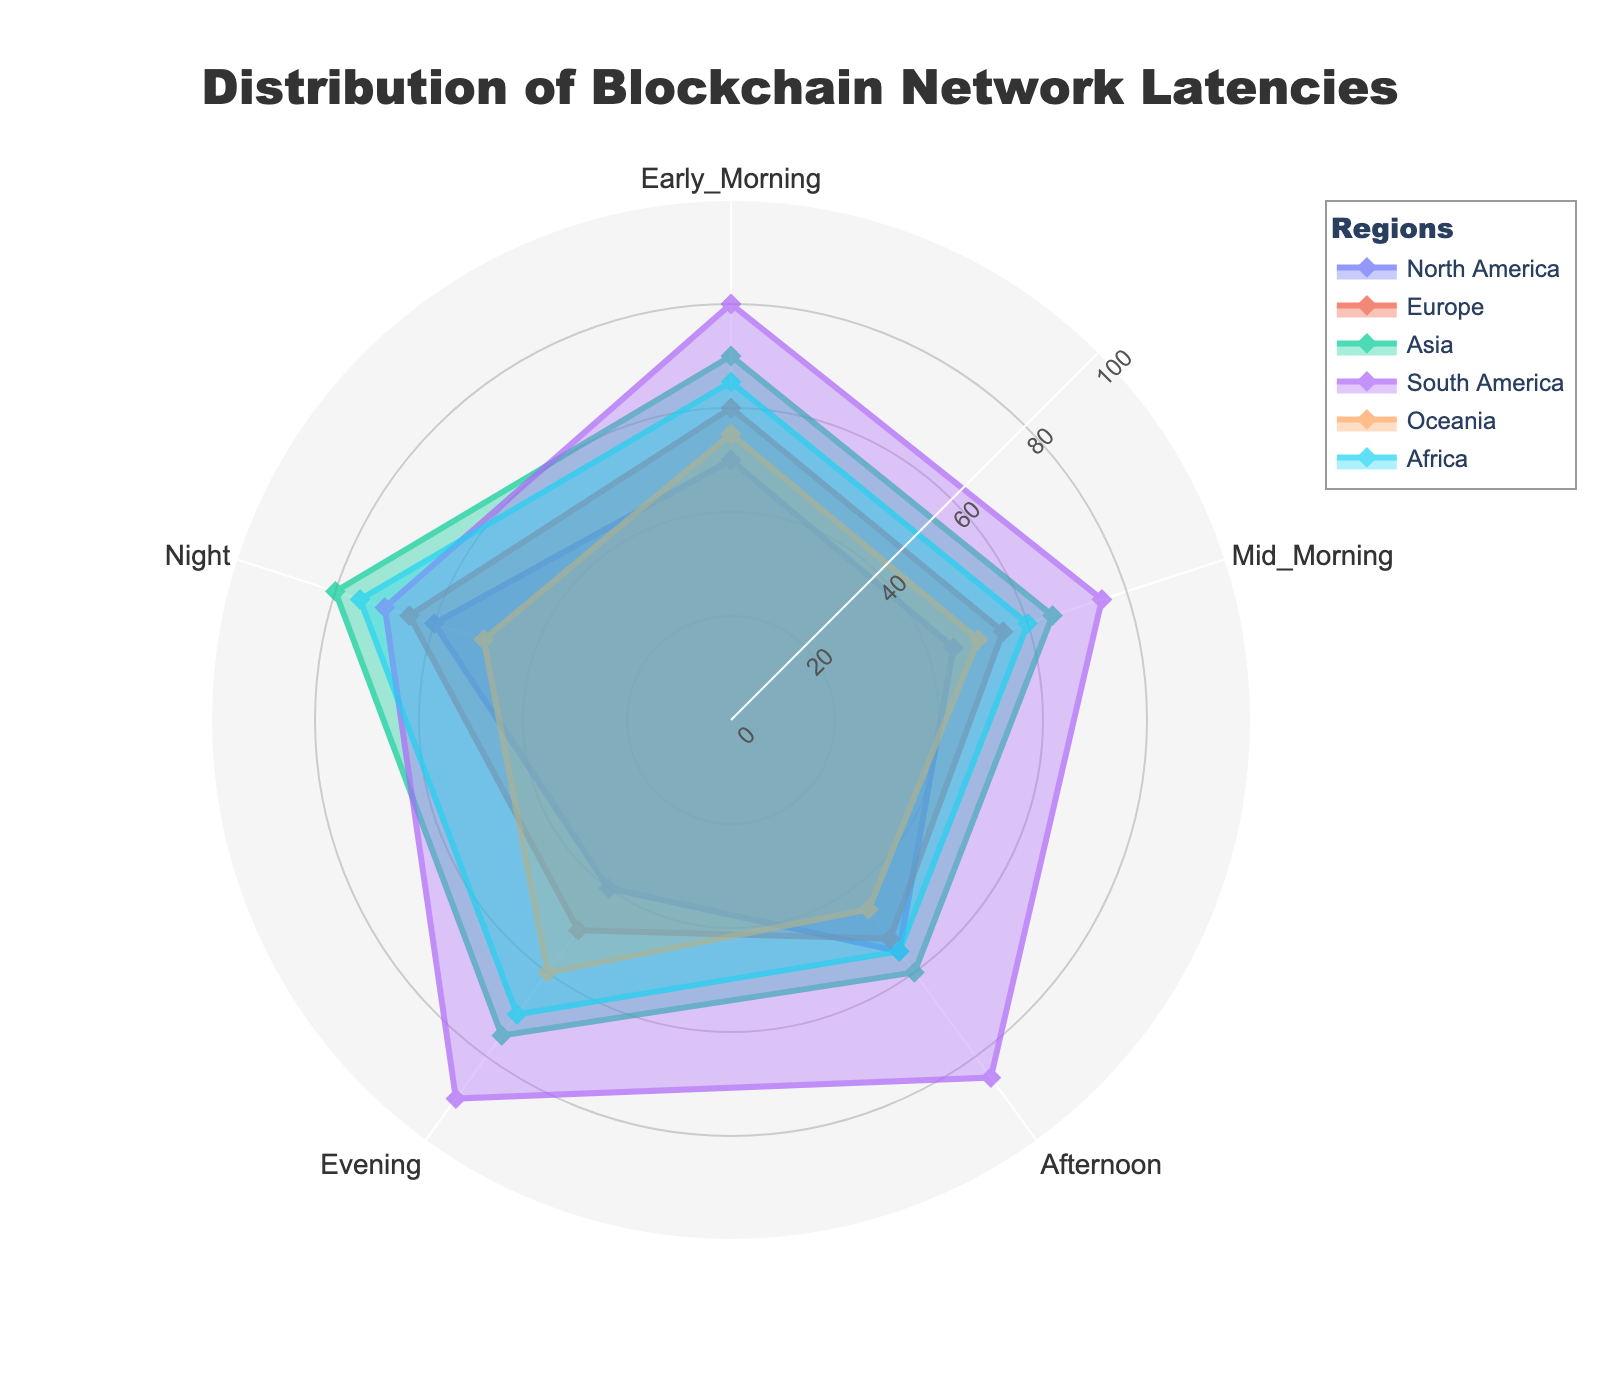What's the title of the radar chart? The title of the radar chart is written at the top center of the figure. It reads "Distribution of Blockchain Network Latencies".
Answer: Distribution of Blockchain Network Latencies Which region experiences the highest latencies in the early morning? Look at the 'Early Morning' axis and determine which region extends the furthest from the center point. The region that has the highest values in the early morning in the radar chart is South America.
Answer: South America Which region has the lowest average latency across all times of day? To find this, take the average of the latencies for each region and compare them. North America has the lowest average latency (50+45+55+40+60 = 250; 250/5 = 50).
Answer: North America What is the difference in latency between Europe and Oceania during the afternoon? Refer to the 'Afternoon' axis and read the values for Europe (52) and Oceania (45). Subtract the smaller value from the larger value (52 - 45).
Answer: 7 During which time of day does Africa experience its highest latency? Look at the latencies for Africa on the radar chart and find the time of day with the highest value. Africa experiences its highest latency during the night.
Answer: Night Which time of day shows similar latency for both Asia and Europe? Compare the plots for Asia and Europe to identify a time of day where the values are close or equal. In the 'Afternoon', Asia has 60 and Europe has 52, which are relatively close.
Answer: Afternoon How does the evening latency in South America compare to that in Oceania? Look at the 'Evening' axis and compare the lengths of the respective region lines. South America shows a value of 90, while Oceania shows a value of 60. South America has higher latency.
Answer: South America > Oceania What is the median latency value for North America throughout the day? The latencies for North America are 50, 45, 55, 40, 60. Arrange these values in ascending order (40, 45, 50, 55, 60) and find the median, which is the middle value.
Answer: 50 Is there any time of day where all regions have latencies above 50? Examine each axis for times of day and check if all regions have values above 50. For 'Night', Asia (80), Europe (65), North America (60), South America (70), and Africa (75) all have values above 50, but Oceania has a value exactly at 50. Hence, no.
Answer: No Which region has the greatest fluctuation in latency throughout the day? Calculate the range (max - min) of latencies for each region. South America varies the most with values from 70 to 90, giving a fluctuation range of 20.
Answer: South America 